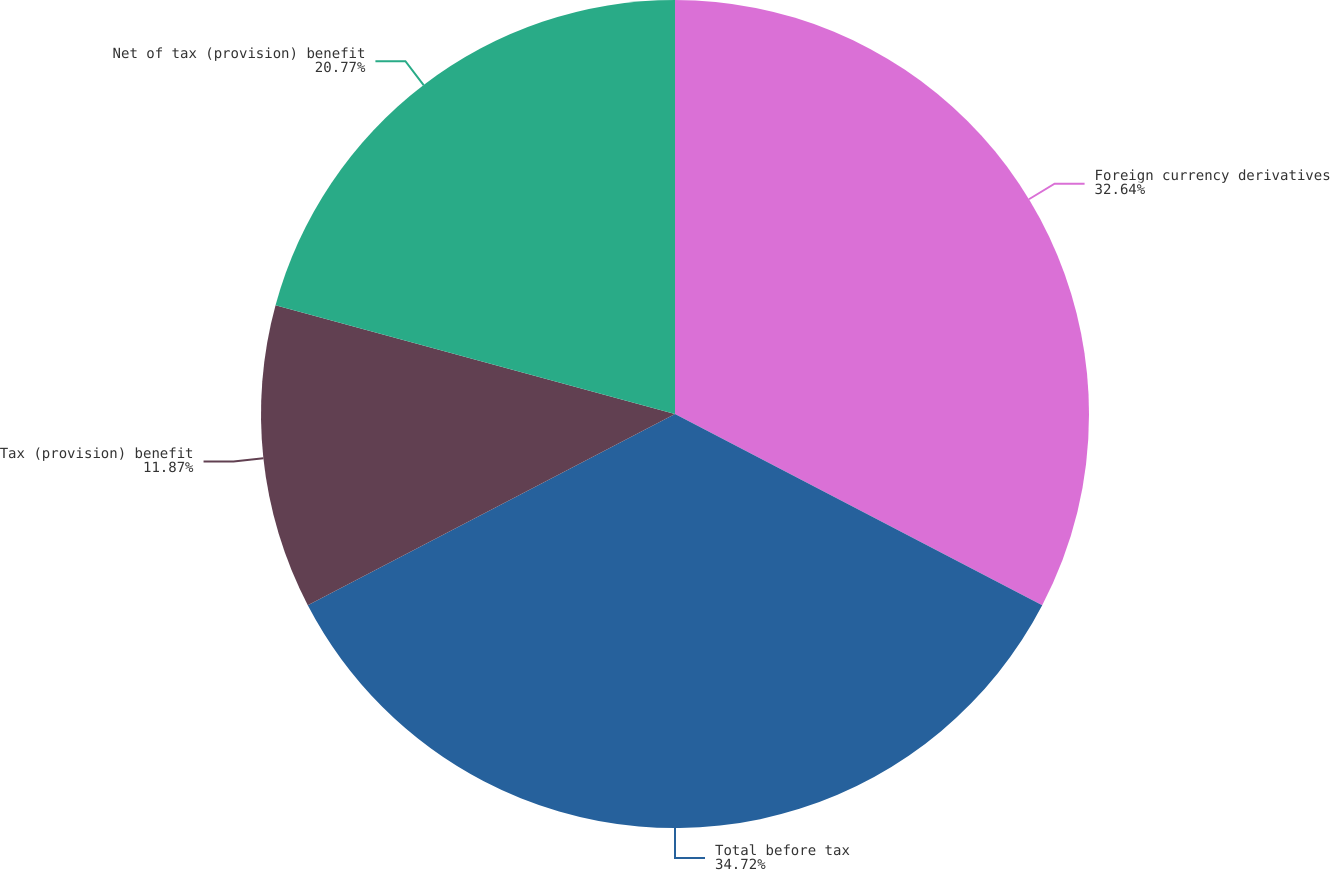<chart> <loc_0><loc_0><loc_500><loc_500><pie_chart><fcel>Foreign currency derivatives<fcel>Total before tax<fcel>Tax (provision) benefit<fcel>Net of tax (provision) benefit<nl><fcel>32.64%<fcel>34.72%<fcel>11.87%<fcel>20.77%<nl></chart> 